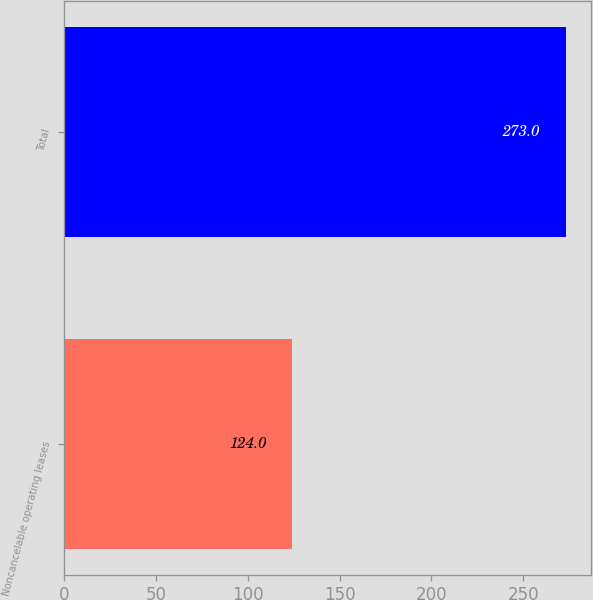Convert chart. <chart><loc_0><loc_0><loc_500><loc_500><bar_chart><fcel>Noncancelable operating leases<fcel>Total<nl><fcel>124<fcel>273<nl></chart> 